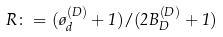<formula> <loc_0><loc_0><loc_500><loc_500>R \colon = ( \tau ^ { ( D ) } _ { d } + 1 ) / ( 2 B _ { D } ^ { ( D ) } + 1 )</formula> 